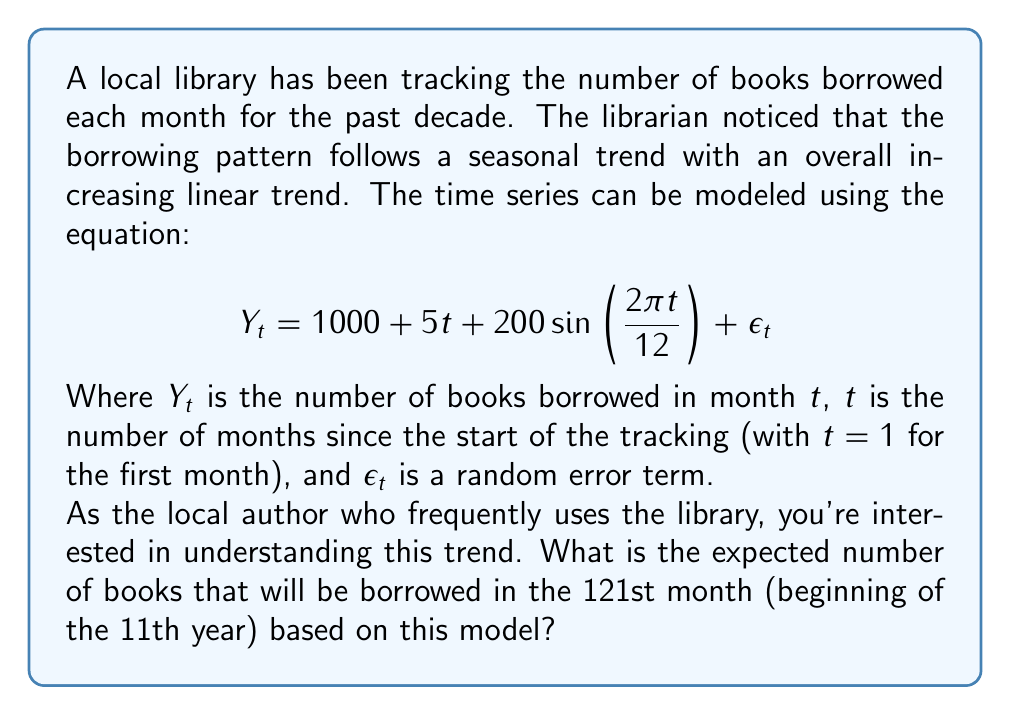Show me your answer to this math problem. To solve this problem, we need to use the given time series model and plug in the appropriate value for $t$. Let's break it down step-by-step:

1) The model is given as:
   $$Y_t = 1000 + 5t + 200\sin(\frac{2\pi t}{12}) + \epsilon_t$$

2) We're asked about the 121st month, so $t = 121$.

3) Let's substitute this value into each component of the equation:

   a) The constant term: 1000

   b) The linear trend: $5t = 5 * 121 = 605$

   c) The seasonal component: 
      $$200\sin(\frac{2\pi t}{12}) = 200\sin(\frac{2\pi * 121}{12})$$
      
      To simplify this:
      $$\frac{2\pi * 121}{12} = 2\pi * 10.0833 = 20.1667\pi$$
      
      $\sin(20.1667\pi) \approx \sin(0.1667\pi) \approx 0.5$
      
      So, $200\sin(\frac{2\pi * 121}{12}) \approx 200 * 0.5 = 100$

   d) We ignore the error term $\epsilon_t$ as we're calculating the expected value.

4) Now, we can sum up all these components:

   $$Y_{121} = 1000 + 605 + 100 = 1705$$

Therefore, the expected number of books borrowed in the 121st month is 1,705.
Answer: 1,705 books 